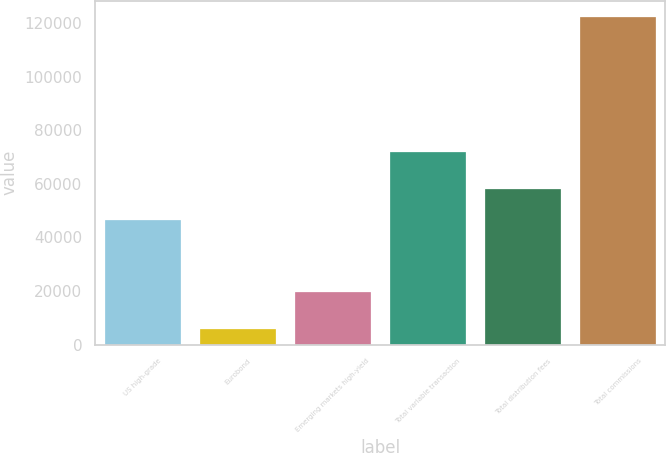<chart> <loc_0><loc_0><loc_500><loc_500><bar_chart><fcel>US high-grade<fcel>Eurobond<fcel>Emerging markets high-yield<fcel>Total variable transaction<fcel>Total distribution fees<fcel>Total commissions<nl><fcel>46329<fcel>5963<fcel>19728<fcel>72020<fcel>57950.7<fcel>122180<nl></chart> 